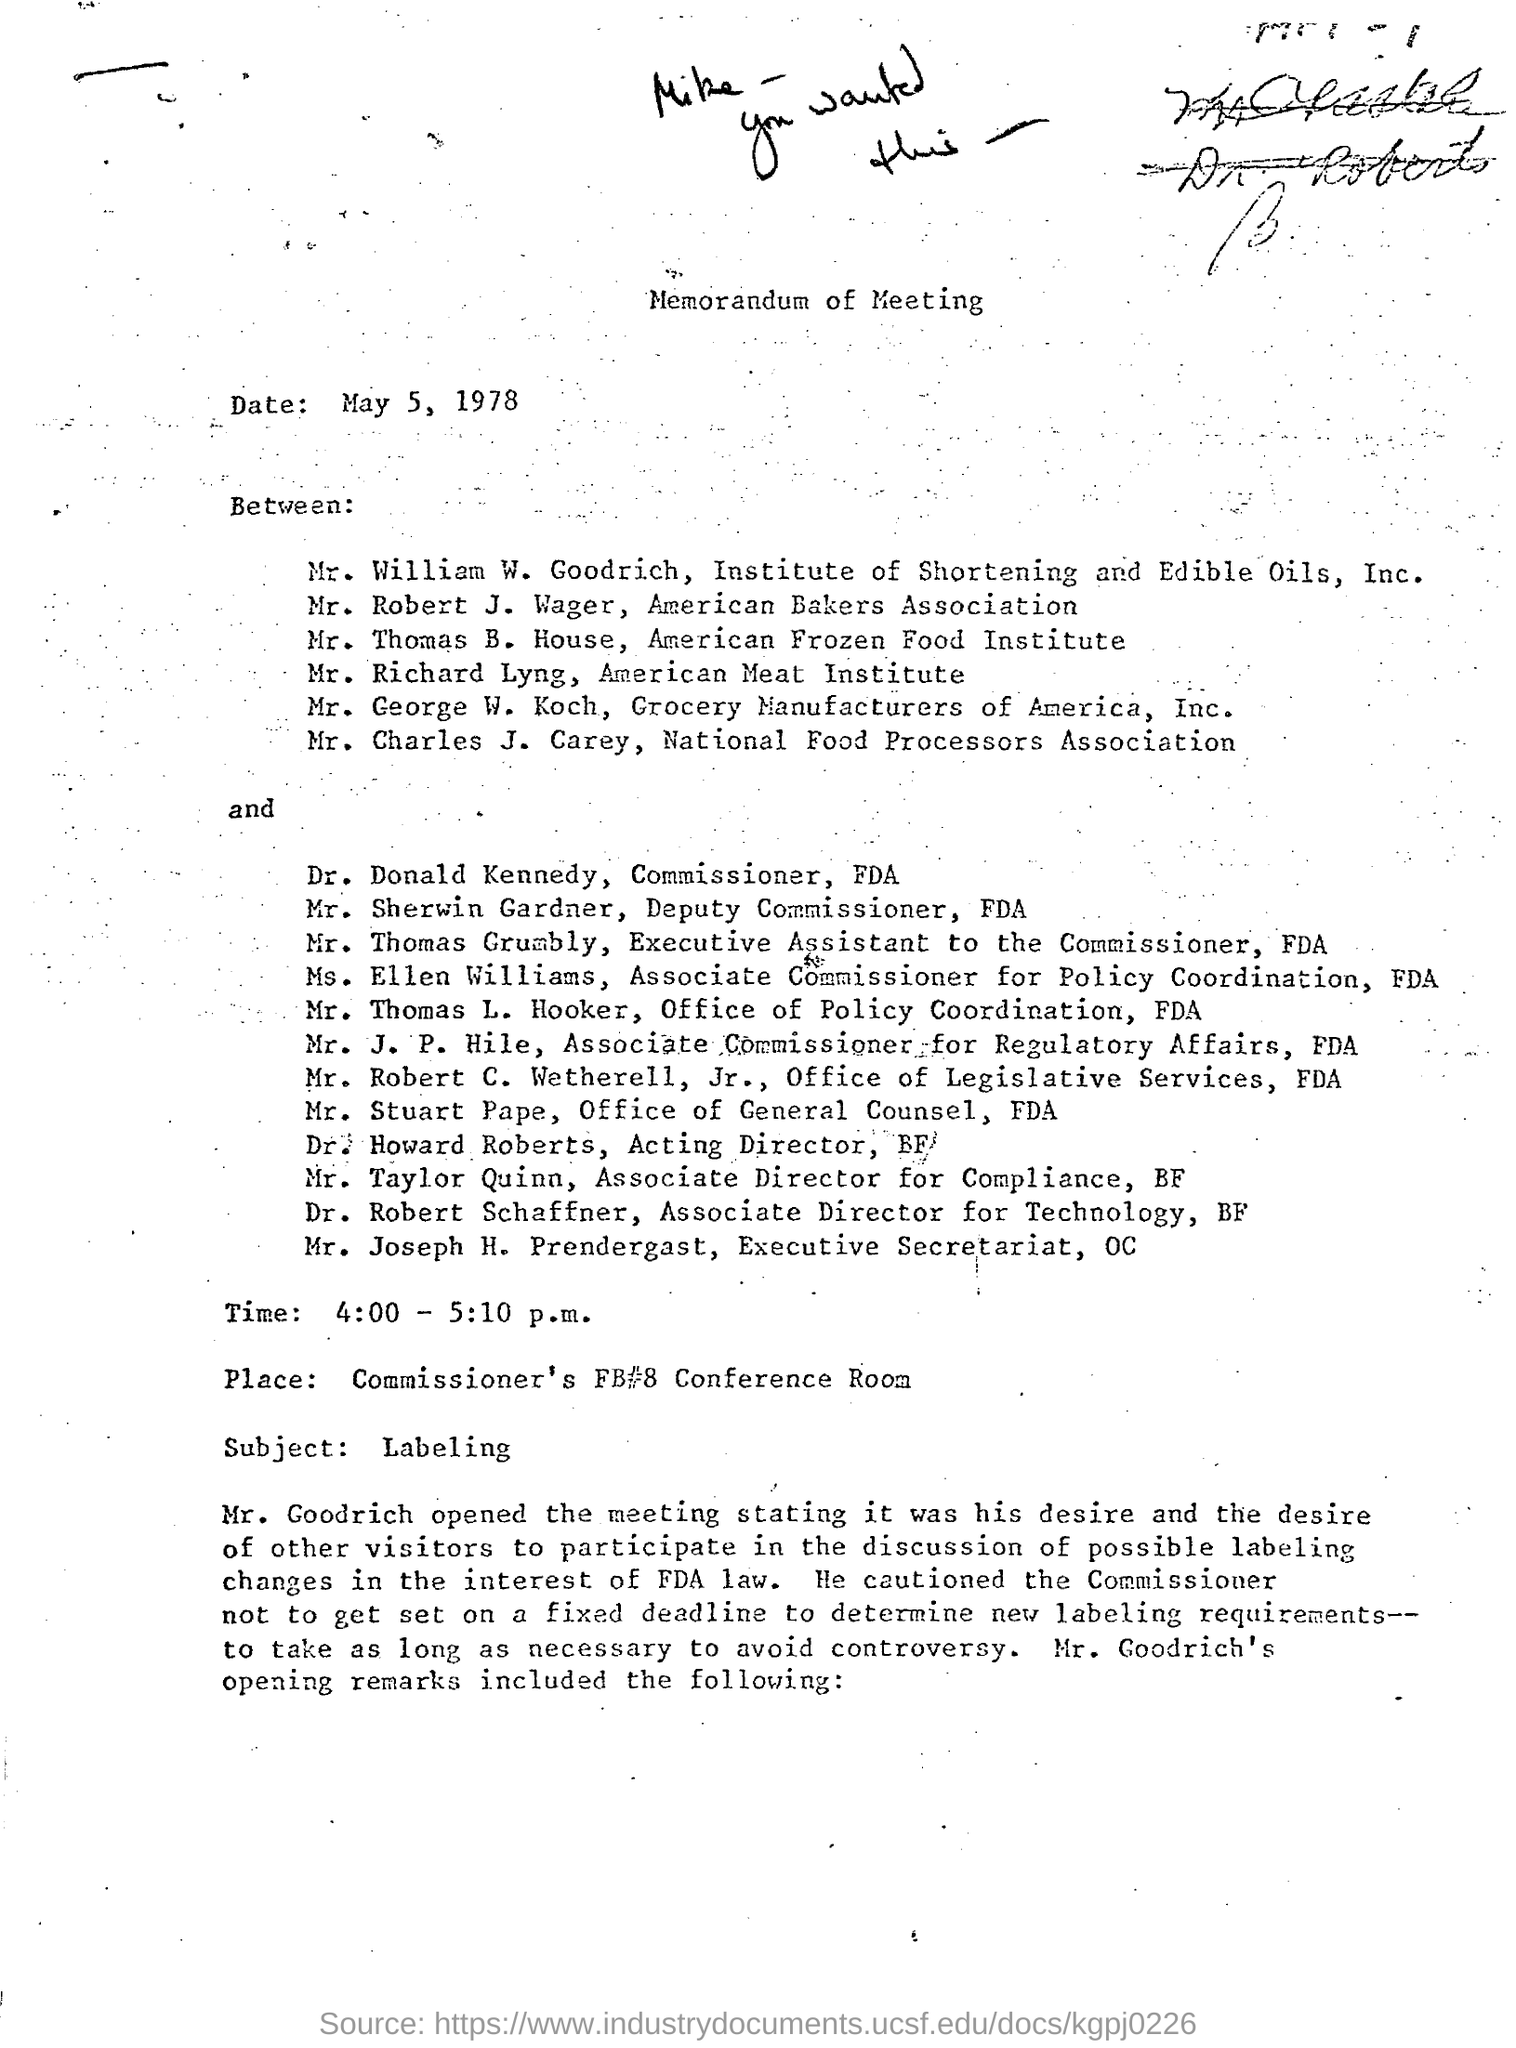What is the heading of the document of the document
Offer a terse response. Memorandum of Meeting. What place is mentioned  in document
Make the answer very short. Commissioner's fb#8 conference room. What is the subject of document?
Make the answer very short. Labeling. 